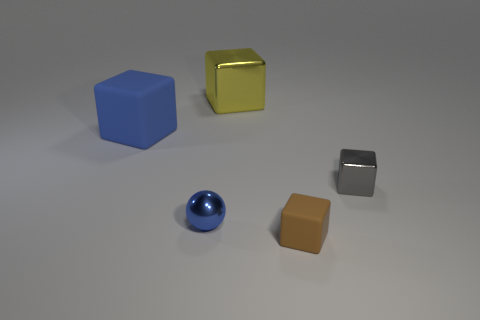Are there any other things that are the same shape as the blue metallic object?
Provide a succinct answer. No. How many blocks are either shiny things or small things?
Your response must be concise. 3. How many other things are the same material as the large yellow block?
Ensure brevity in your answer.  2. There is a big object behind the blue cube; what is its shape?
Offer a very short reply. Cube. There is a small gray object that is in front of the big block behind the blue block; what is it made of?
Your response must be concise. Metal. Are there more blue metal objects that are on the left side of the tiny brown rubber thing than tiny red spheres?
Your answer should be very brief. Yes. How many other things are the same color as the small rubber cube?
Offer a terse response. 0. The rubber object that is the same size as the ball is what shape?
Offer a terse response. Cube. What number of tiny metal things are behind the matte object that is to the right of the metal cube that is to the left of the tiny brown rubber object?
Offer a terse response. 2. What number of rubber things are either tiny balls or small brown spheres?
Keep it short and to the point. 0. 